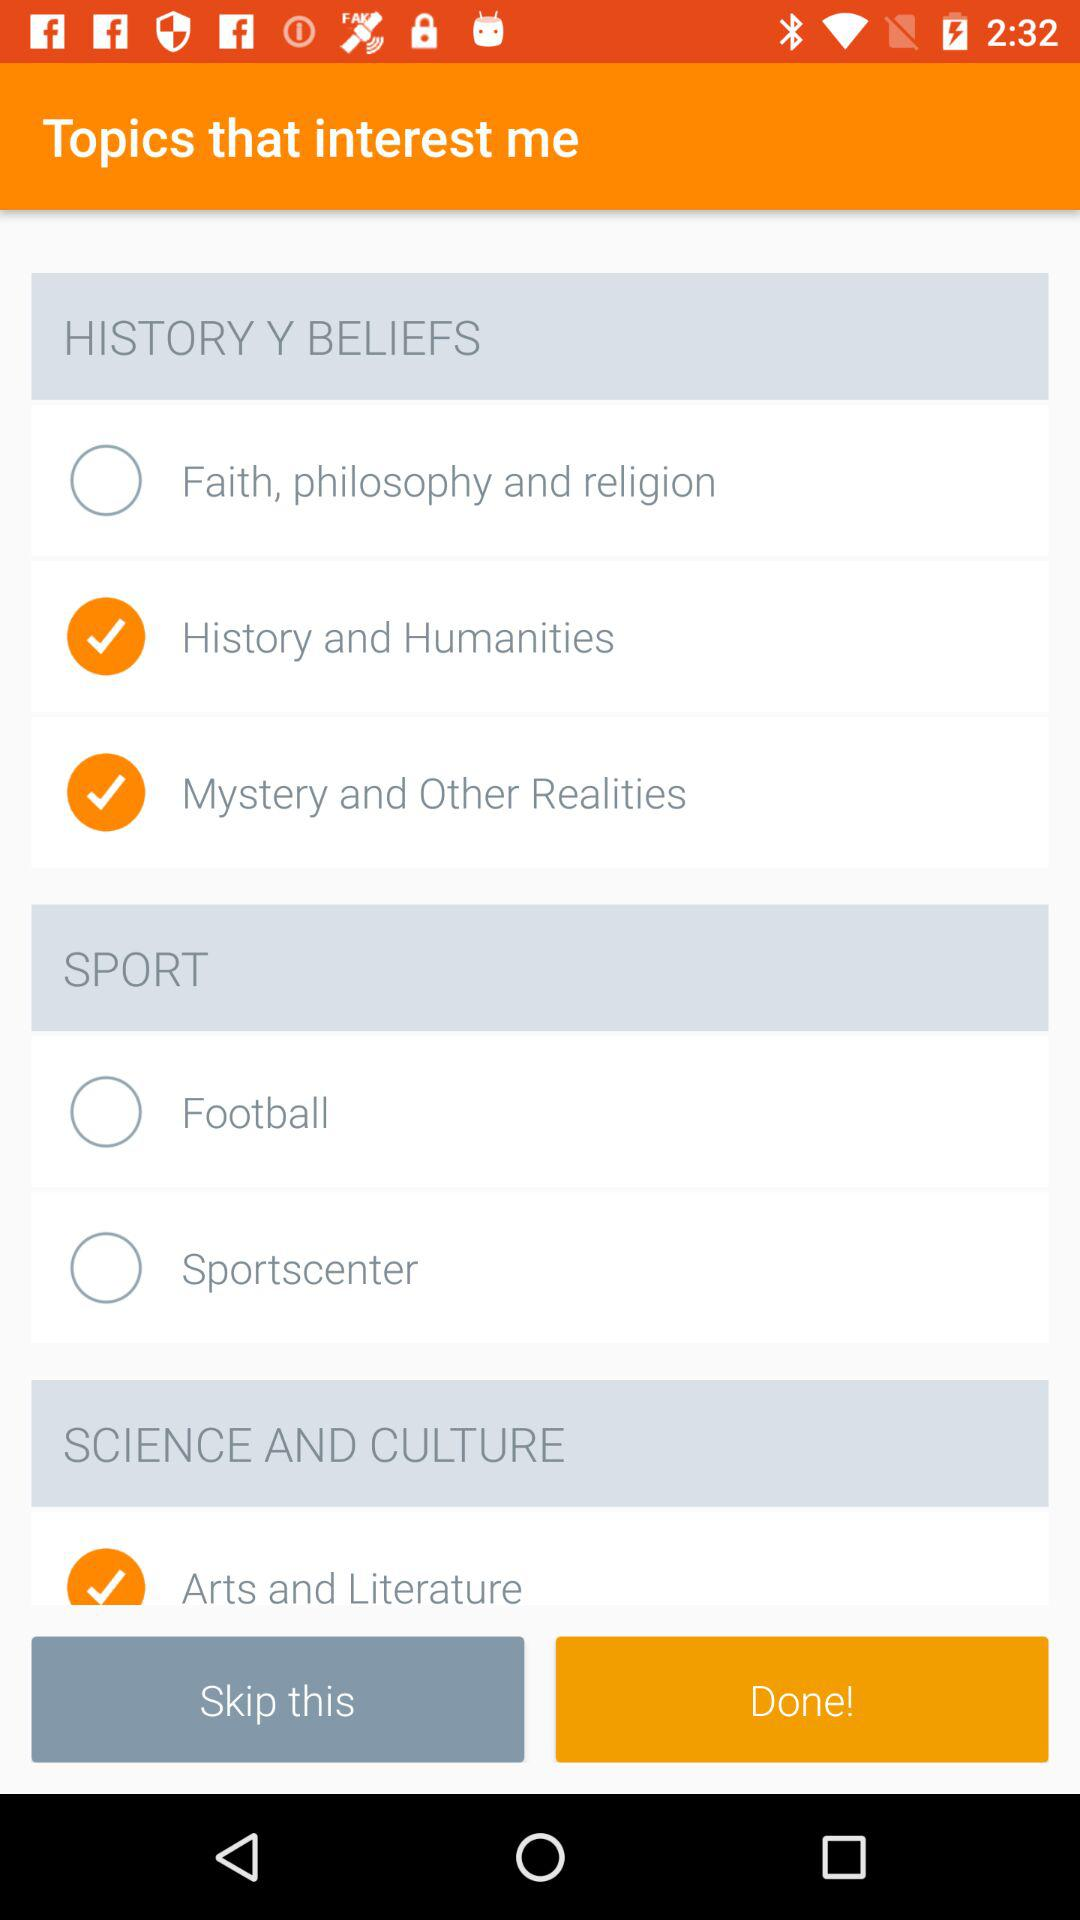What is the status of "Sportscenter"? The status is off. 